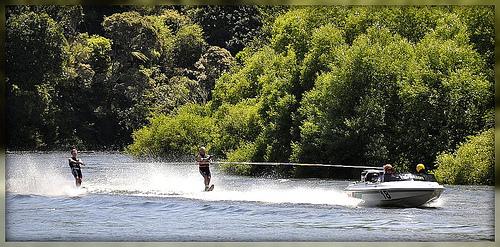How many skiers can be seen?
Keep it brief. 2. What device is empowering the man to be above the water?
Concise answer only. Boat. What sport is being shown?
Answer briefly. Water skiing. Are they using a specialized boat for this sport?
Write a very short answer. Yes. 